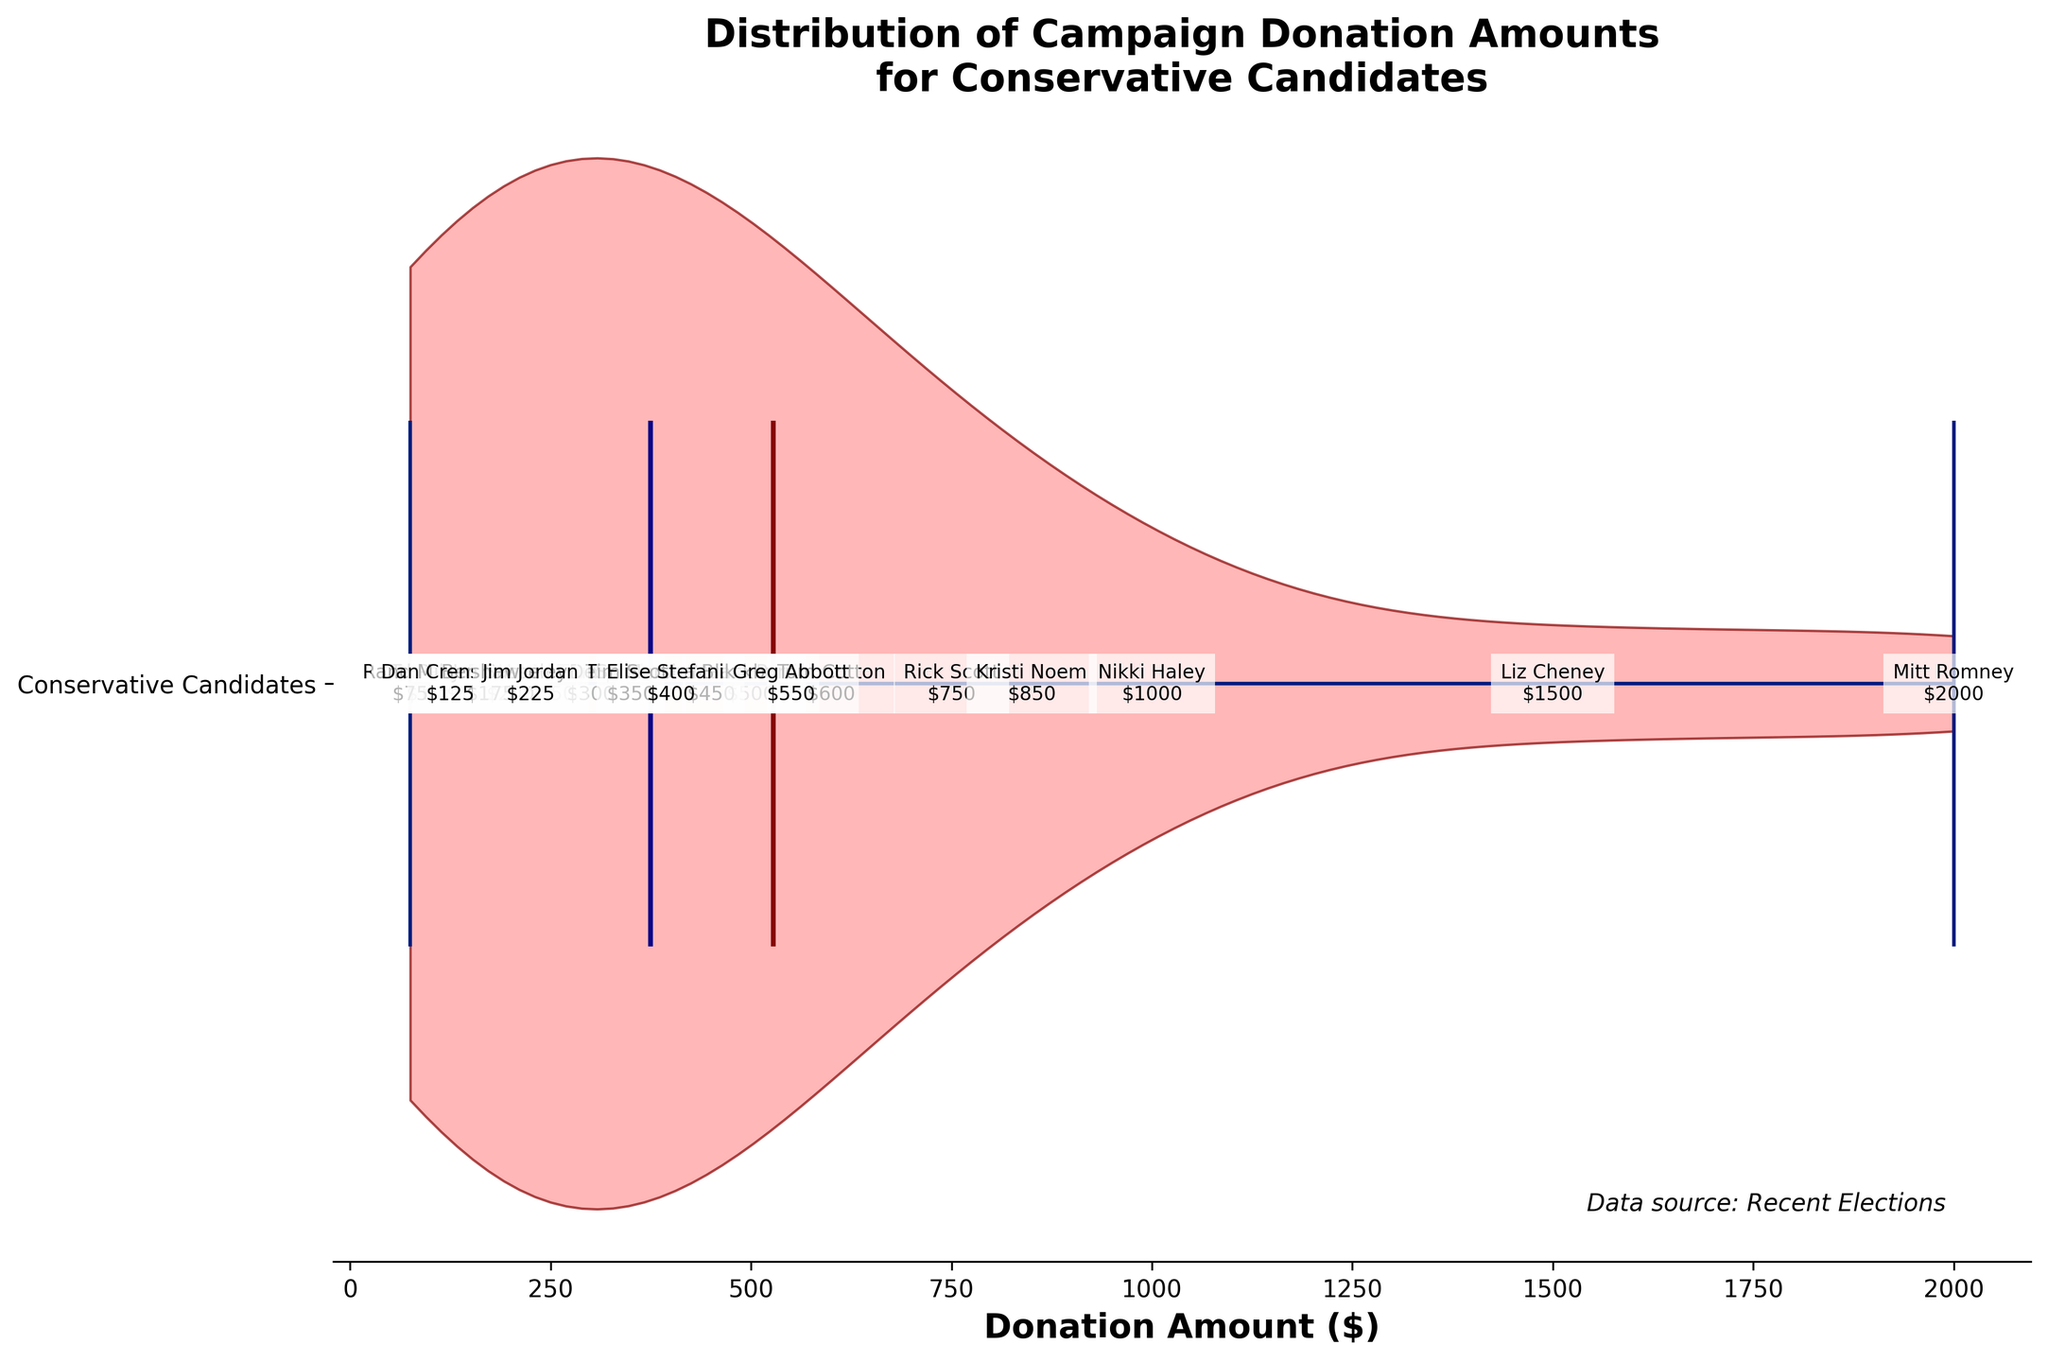What's the title of the figure? The title is displayed at the top of the figure. It reads "Distribution of Campaign Donation Amounts for Conservative Candidates."
Answer: Distribution of Campaign Donation Amounts for Conservative Candidates What does the dark blue line in the plot represent? The dark blue line signifies the median donation amount for conservative candidates, which is visually represented within the plot.
Answer: Median donation amount Which candidate received the highest donation amount and what is it? The candidate with the highest donation amount is indicated with the largest labeled donation value. This is $2000, attributed to Mitt Romney.
Answer: Mitt Romney, $2000 How is the mean donation amount represented visually in the plot? The mean donation amount is represented by a central red line within the violin plot, which is labeled as the mean.
Answer: Central red line What can you say about the spread of donation amounts? The spread of donation amounts can be interpreted by observing the width and shape of the violin plot, which shows a distribution of values ranging mainly from $75 to $2000 with the wider portions indicating more frequent donation amounts.
Answer: Ranges from $75 to $2000, wider portions indicate more frequent amounts Identify the candidate with the median donation amount and state the value. The candidate with the donation amount closest to the visual median blue line in the plot is Greg Abbott with $550.
Answer: Greg Abbott, $550 How many candidates received donations below $300? Visually count the candidates annotated with donation amounts below the $300 mark. This includes candidates like Rand Paul, Ted Cruz, Dan Crenshaw, Ben Sasse, and Jim Jordan.
Answer: 5 candidates What's the difference between the highest and the median donation amounts? Identify the highest donation amount, $2000, and the median donation amount, $550. Subtract the median from the highest: $2000 - $550 = $1450.
Answer: $1450 Which candidate received a donation amount just above the mean? Visually locate the red mean line in the plot and identify the closest higher donation amount, which is $600 attributed to Tom Cotton.
Answer: Tom Cotton, $600 Compare the donation amounts between Donald Trump and Josh Hawley. Which one is higher and by how much? Observe the donation amounts for both candidates. Donald Trump received $250 and Josh Hawley received $200. Calculate the difference: $250 - $200 = $50.
Answer: Donald Trump, $50 